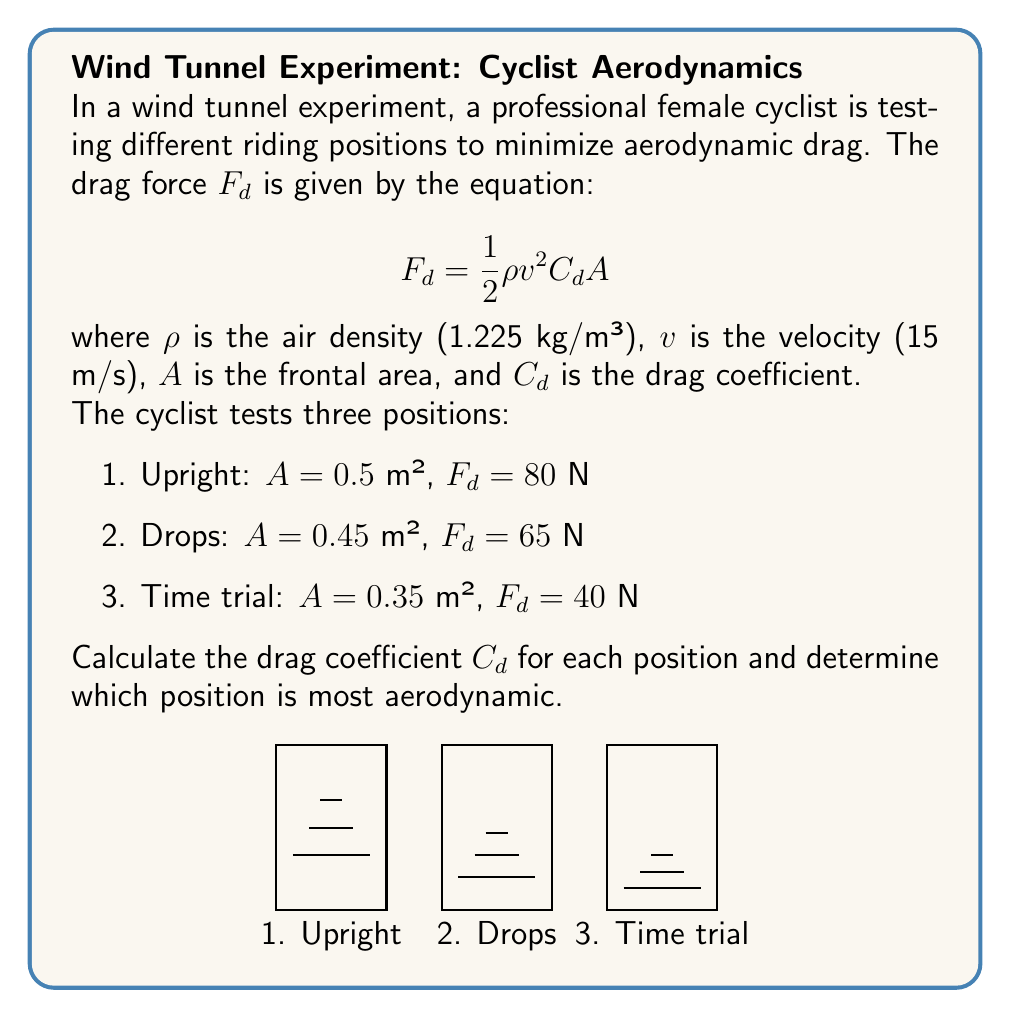Provide a solution to this math problem. Let's solve this problem step by step using the given equation:

$$F_d = \frac{1}{2} \rho v^2 C_d A$$

We need to rearrange this equation to solve for $C_d$:

$$C_d = \frac{2F_d}{\rho v^2 A}$$

Now, let's calculate $C_d$ for each position:

1. Upright position:
   $$C_d = \frac{2 \cdot 80}{1.225 \cdot 15^2 \cdot 0.5} = 0.5805$$

2. Drops position:
   $$C_d = \frac{2 \cdot 65}{1.225 \cdot 15^2 \cdot 0.45} = 0.5241$$

3. Time trial position:
   $$C_d = \frac{2 \cdot 40}{1.225 \cdot 15^2 \cdot 0.35} = 0.4138$$

The most aerodynamic position is the one with the lowest drag coefficient. In this case, it's the time trial position with a $C_d$ of 0.4138.
Answer: Upright: $C_d = 0.5805$
Drops: $C_d = 0.5241$
Time trial: $C_d = 0.4138$
Most aerodynamic: Time trial position 